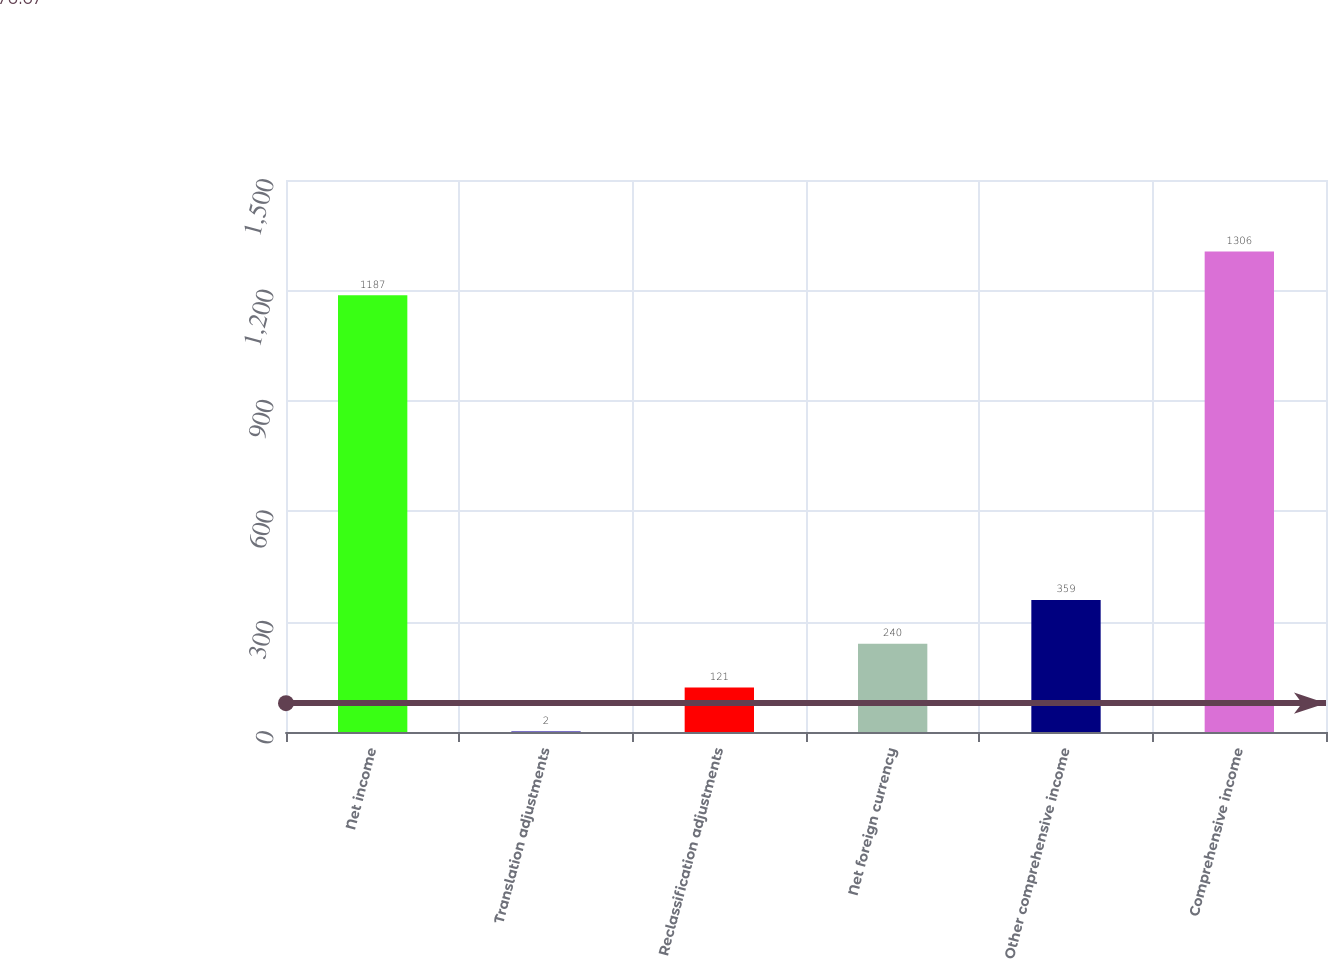Convert chart. <chart><loc_0><loc_0><loc_500><loc_500><bar_chart><fcel>Net income<fcel>Translation adjustments<fcel>Reclassification adjustments<fcel>Net foreign currency<fcel>Other comprehensive income<fcel>Comprehensive income<nl><fcel>1187<fcel>2<fcel>121<fcel>240<fcel>359<fcel>1306<nl></chart> 